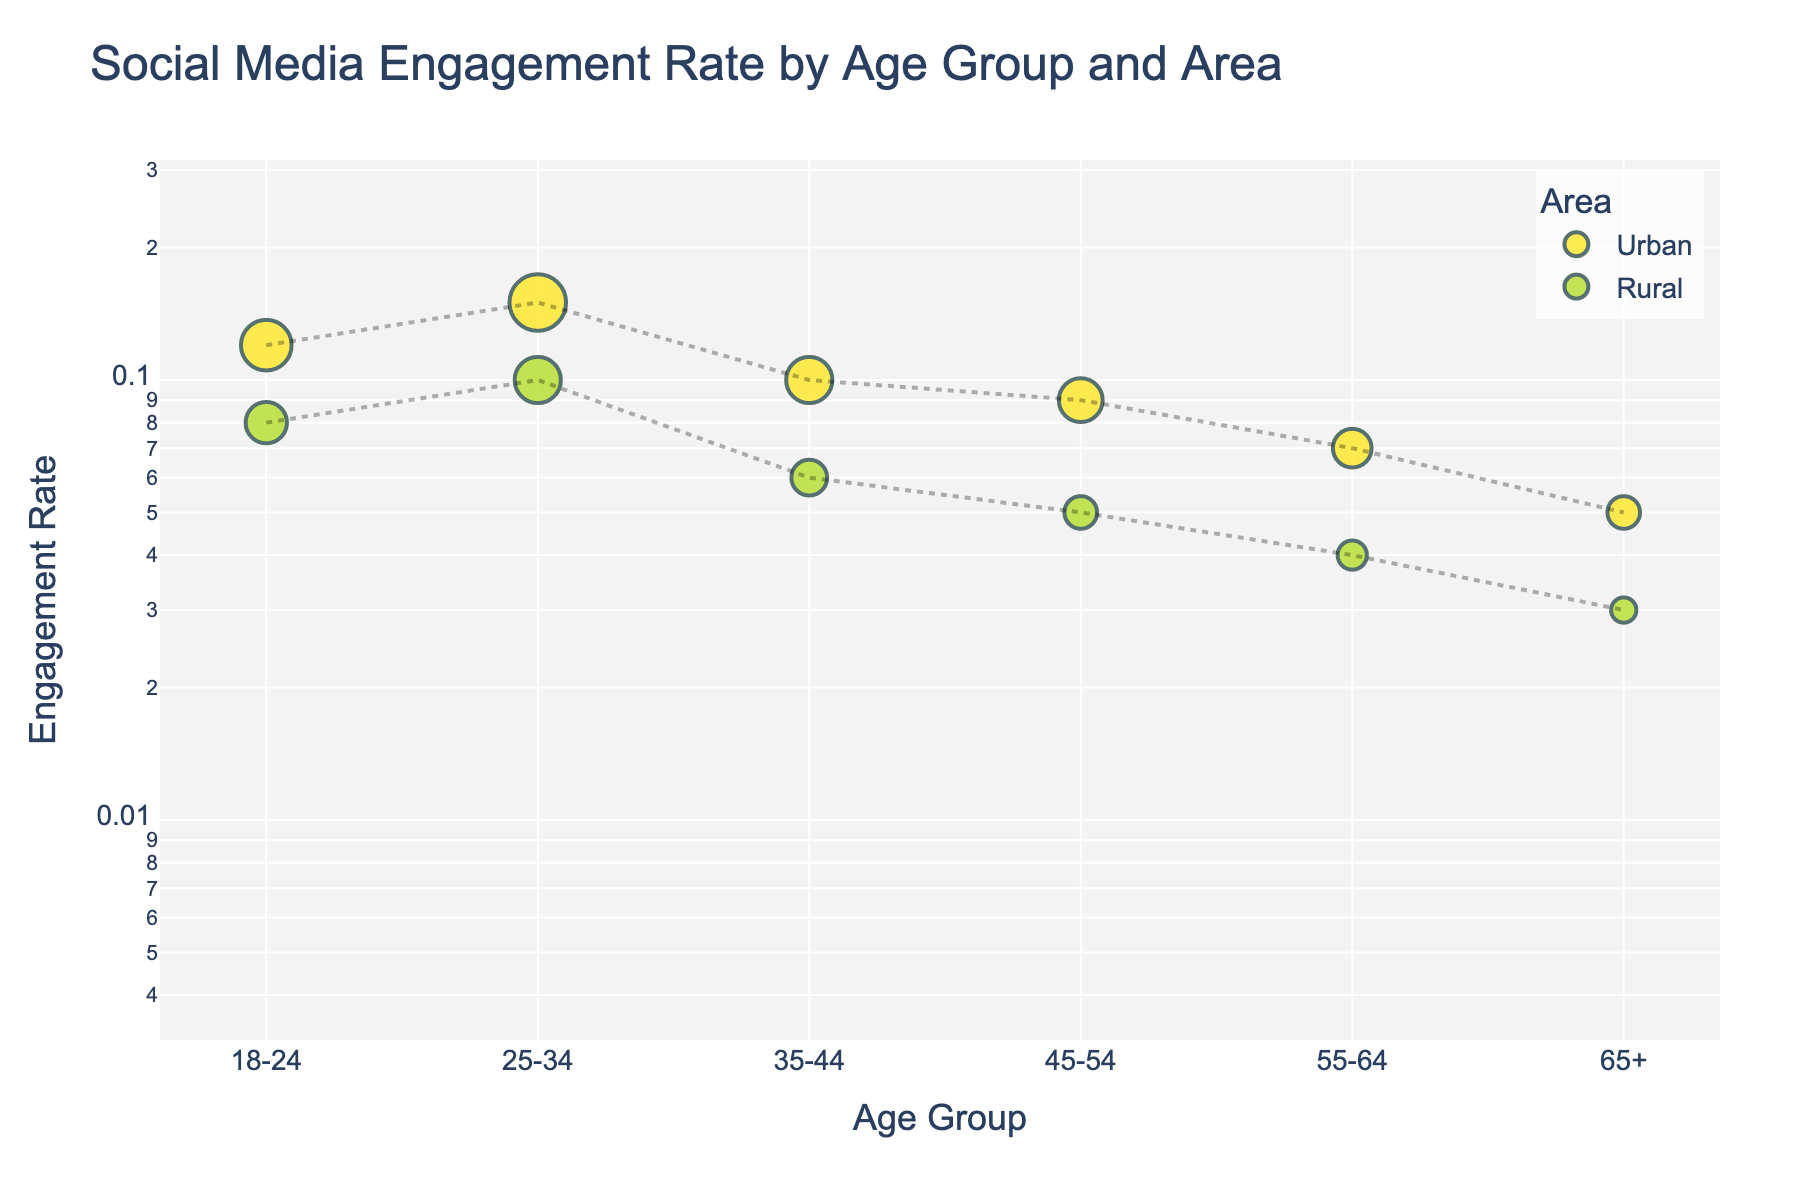What's the title of the figure? The title of the figure is displayed at the top, summarizing the content of the plot. It reads "Social Media Engagement Rate by Age Group and Area."
Answer: Social Media Engagement Rate by Age Group and Area Which age group has the highest engagement rate in urban areas? From the scatter plot, look at "Urban" points and identify the highest y-value. The 25-34 age group has the highest engagement rate in urban areas with a value of 0.15.
Answer: 25-34 How does the average engagement rate compare between urban and rural areas? Calculate the average engagement rate for both urban and rural areas. For urban: (0.12 + 0.15 + 0.10 + 0.09 + 0.07 + 0.05) / 6 = 0.0967. For rural: (0.08 + 0.10 + 0.06 + 0.05 + 0.04 + 0.03) / 6 = 0.06. Therefore, the average engagement rate in urban areas is higher than in rural areas.
Answer: Urban: 0.0967, Rural: 0.06 What is the difference in engagement rate for the 18-24 age group between urban and rural areas? Look at the engagement rates for the 18-24 age group. Urban has 0.12 and Rural has 0.08. Calculate the difference: 0.12 - 0.08 = 0.04.
Answer: 0.04 Is the engagement rate generally higher in urban or rural areas across age groups? By comparing engagement rates at each age group point, it is observed that all urban points are higher than the corresponding rural points. Therefore, the engagement rate is generally higher in urban areas.
Answer: Urban Which age group shows the smallest difference in engagement rate between urban and rural areas? Calculate the differences for each age group and then compare them. 18-24: 0.04, 25-34: 0.05, 35-44: 0.04, 45-54: 0.04, 55-64: 0.03, 65+: 0.02. The smallest difference is in the 65+ age group with 0.02.
Answer: 65+ Do older age groups (55+) show higher engagement rates in rural areas compared to younger groups (18-24)? Compare the engagement rates of 55-64 and 65+ in rural areas with those of 18-24. 18-24 has 0.08, 55-64 has 0.04, and 65+ has 0.03. The younger group has higher engagement rates.
Answer: No Between which two consecutive age groups in urban areas does the engagement rate drop the most? Calculate the differences between consecutive age groups in urban areas. 18-24 to 25-34: 0.03, 25-34 to 35-44: 0.05, 35-44 to 45-54: 0.01, 45-54 to 55-64: 0.02, 55-64 to 65+: 0.02. The largest drop is between 25-34 and 35-44 with a difference of 0.05.
Answer: 25-34 to 35-44 Which area shows a higher consistency in engagement rate across different age groups? Look at the variance in engagement rates for both areas. Urban rates range from 0.05 to 0.15 (0.10 range) and Rural rates range from 0.03 to 0.10 (0.07 range). Rural shows higher consistency.
Answer: Rural 